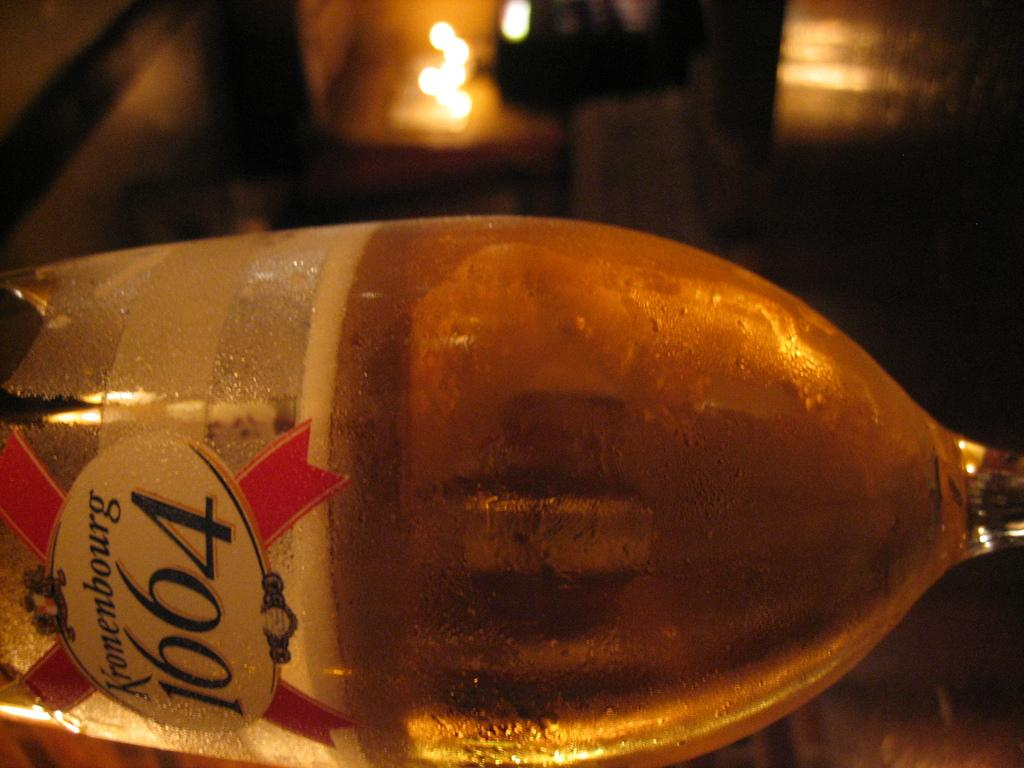<image>
Describe the image concisely. A glass of beer which reads Kronenbourg 1664 on it 